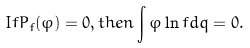<formula> <loc_0><loc_0><loc_500><loc_500>I f P _ { f } ( \varphi ) = 0 , t h e n \int \varphi \ln f d q = 0 .</formula> 